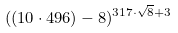Convert formula to latex. <formula><loc_0><loc_0><loc_500><loc_500>( ( 1 0 \cdot 4 9 6 ) - 8 ) ^ { 3 1 7 \cdot \sqrt { 8 } + 3 }</formula> 